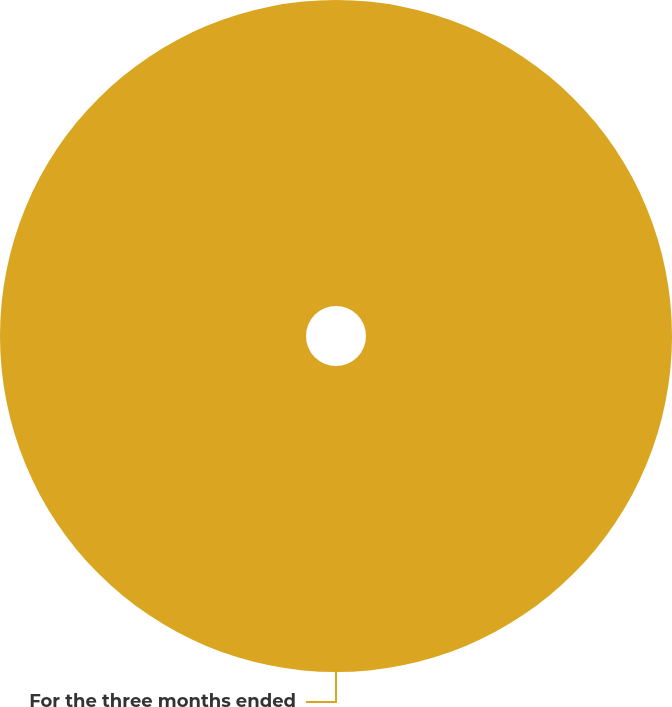Convert chart. <chart><loc_0><loc_0><loc_500><loc_500><pie_chart><fcel>For the three months ended<nl><fcel>100.0%<nl></chart> 